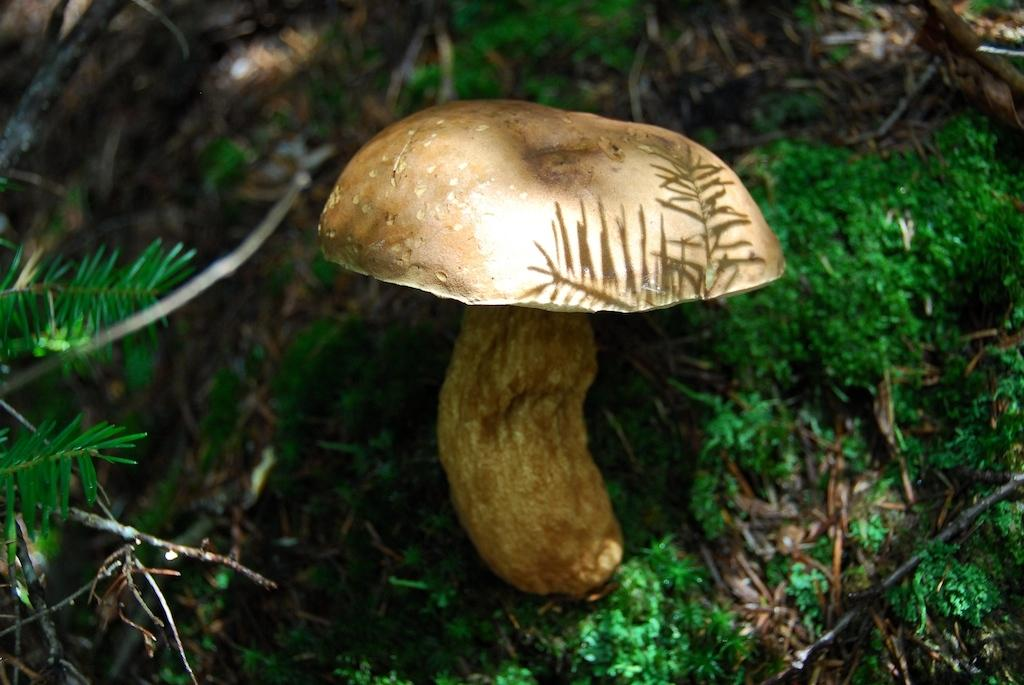What is the main subject in the center of the image? There is a mushroom in the center of the image. What type of vegetation is visible in the image? There is grass and plants visible in the image. How many frogs can be seen hopping around the mushroom in the image? There are no frogs present in the image. What type of card is visible in the image? There is no card present in the image. 